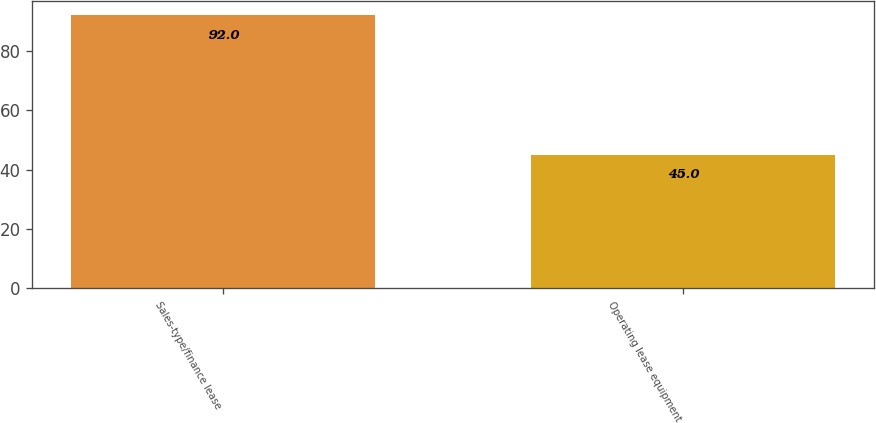Convert chart. <chart><loc_0><loc_0><loc_500><loc_500><bar_chart><fcel>Sales-type/finance lease<fcel>Operating lease equipment<nl><fcel>92<fcel>45<nl></chart> 